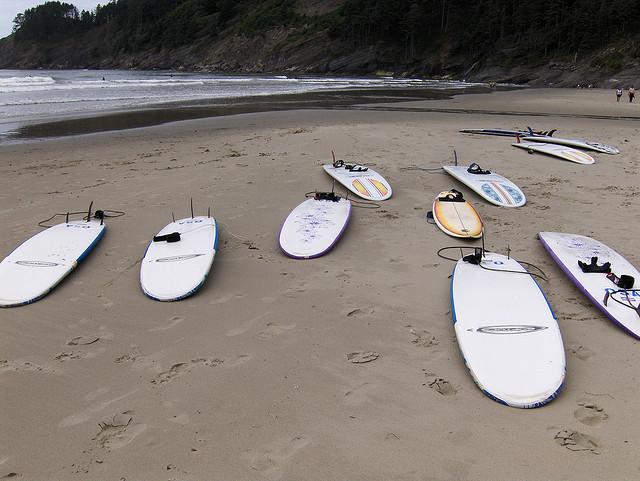Why are all of the surfboards upside down?
Answer briefly. So parts on bottom don't get destroyed. Is the board dirty?
Answer briefly. No. What are the surfboards lying on?
Keep it brief. Sand. How many surfboards are there?
Be succinct. 11. 